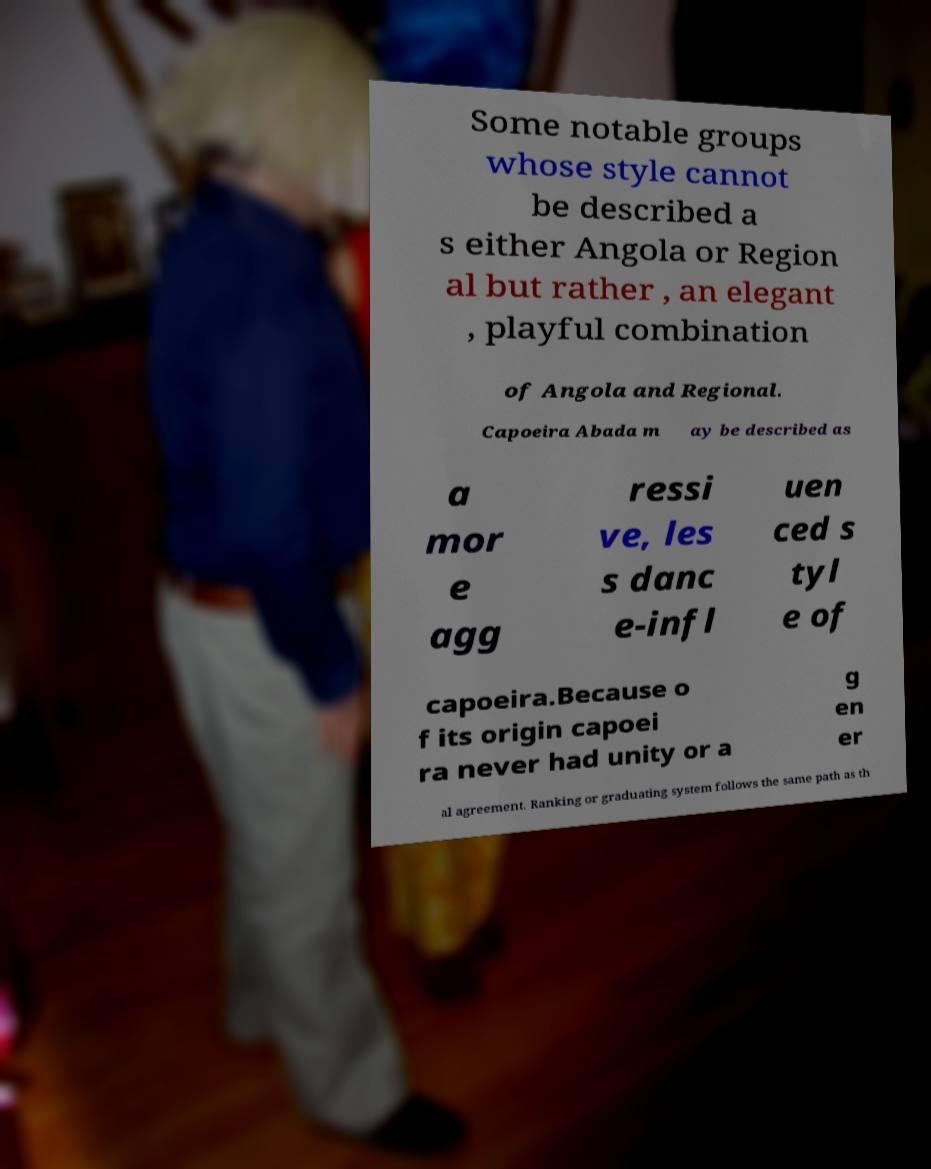Could you assist in decoding the text presented in this image and type it out clearly? Some notable groups whose style cannot be described a s either Angola or Region al but rather , an elegant , playful combination of Angola and Regional. Capoeira Abada m ay be described as a mor e agg ressi ve, les s danc e-infl uen ced s tyl e of capoeira.Because o f its origin capoei ra never had unity or a g en er al agreement. Ranking or graduating system follows the same path as th 